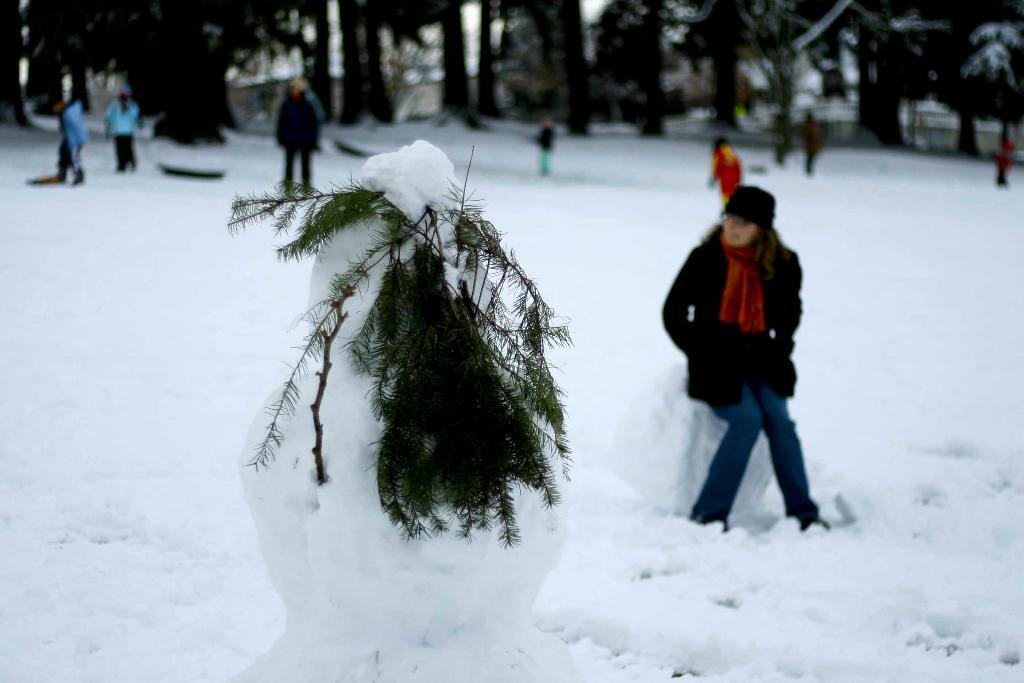How many people are present in the image? There are many people in the image. What are the people wearing in the image? The people are wearing clothes and a cap. What is the weather like in the image? The snow in the image suggests a cold and snowy weather. What is the color of the snow in the image? The snow is white in color. What type of vegetation can be seen in the image? There are many trees in the image. How does the jellyfish feel about the snow in the image? There is no jellyfish present in the image, so it is not possible to determine how it might feel about the snow. 